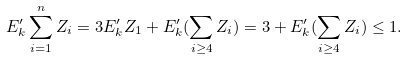Convert formula to latex. <formula><loc_0><loc_0><loc_500><loc_500>E ^ { \prime } _ { k } \sum _ { i = 1 } ^ { n } Z _ { i } = 3 E ^ { \prime } _ { k } Z _ { 1 } + E ^ { \prime } _ { k } ( \sum _ { i \geq 4 } Z _ { i } ) = 3 + E ^ { \prime } _ { k } ( \sum _ { i \geq 4 } Z _ { i } ) \leq 1 .</formula> 